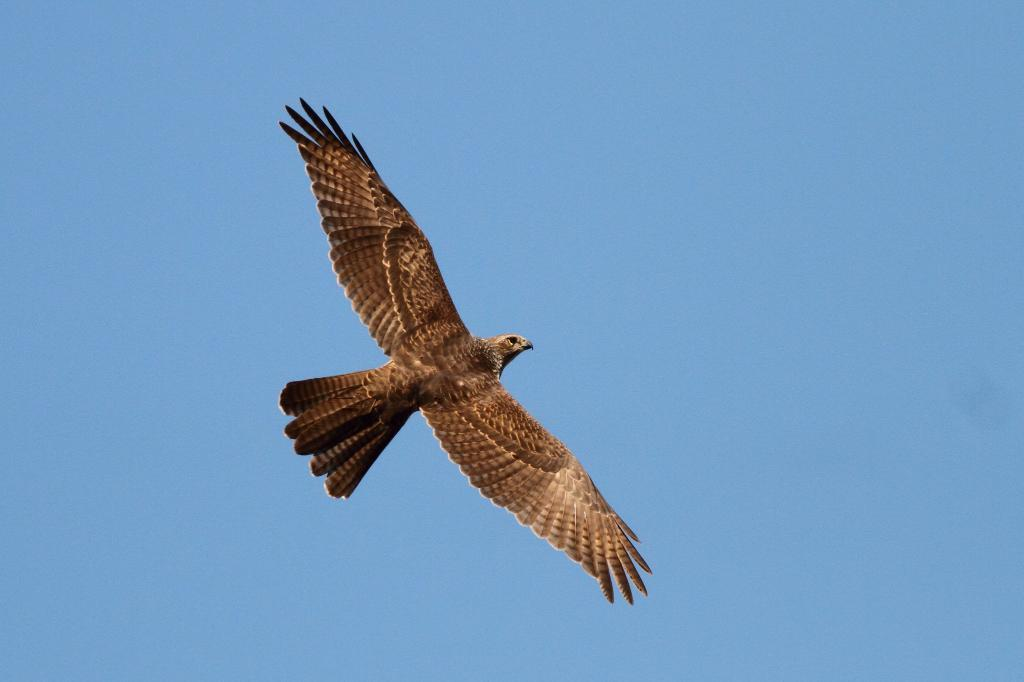What type of animal is present in the image? There is a bird in the image. What is the bird doing in the image? The bird is flying in the sky. Where is the bird located in the image? The bird is in the center of the image. What type of shoes is the bird wearing in the image? There are no shoes present in the image, as the subject is a bird flying in the sky. Is the bird flying over a farm in the image? The provided facts do not mention a farm, so it cannot be determined if the bird is flying over a farm. 